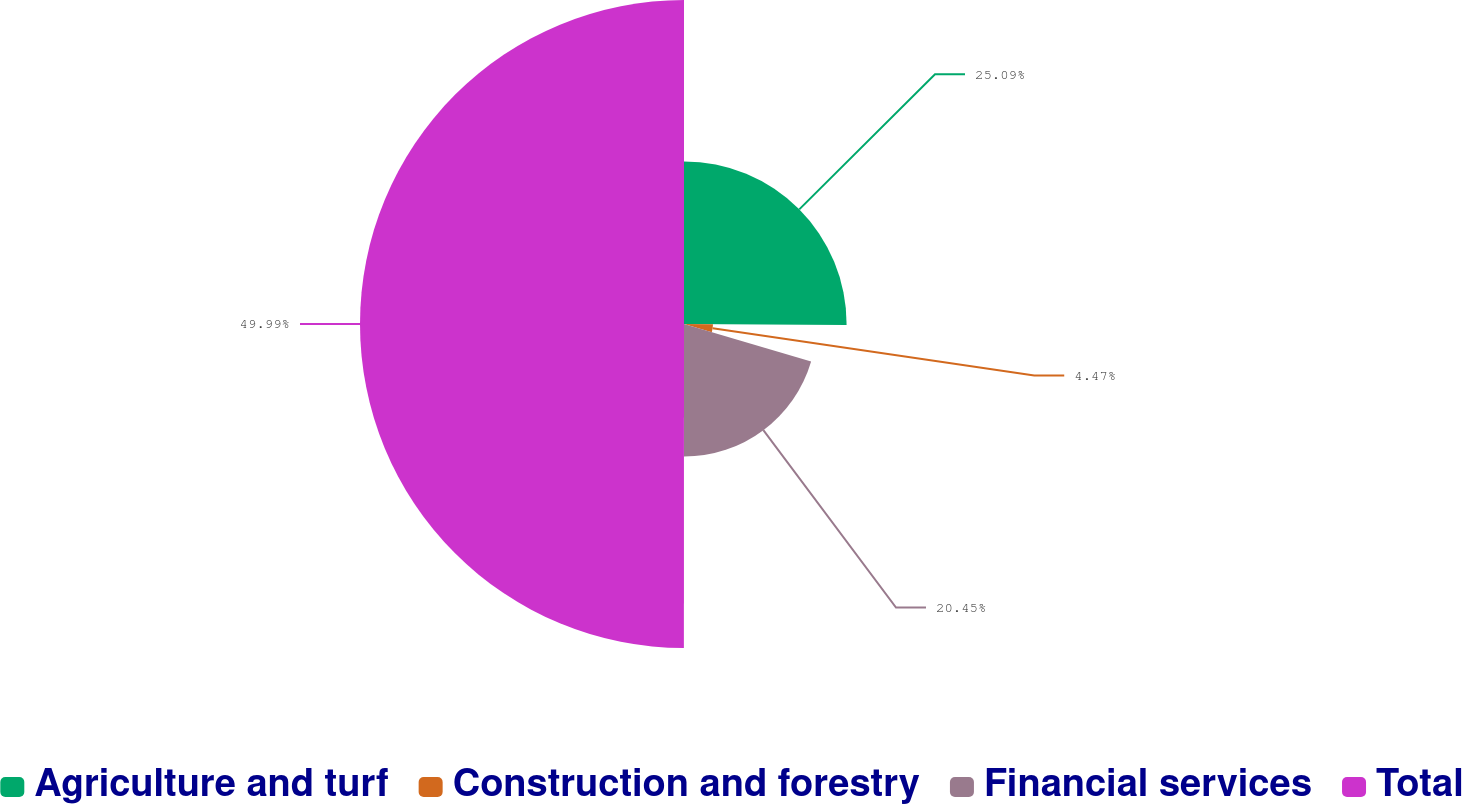<chart> <loc_0><loc_0><loc_500><loc_500><pie_chart><fcel>Agriculture and turf<fcel>Construction and forestry<fcel>Financial services<fcel>Total<nl><fcel>25.09%<fcel>4.47%<fcel>20.45%<fcel>50.0%<nl></chart> 